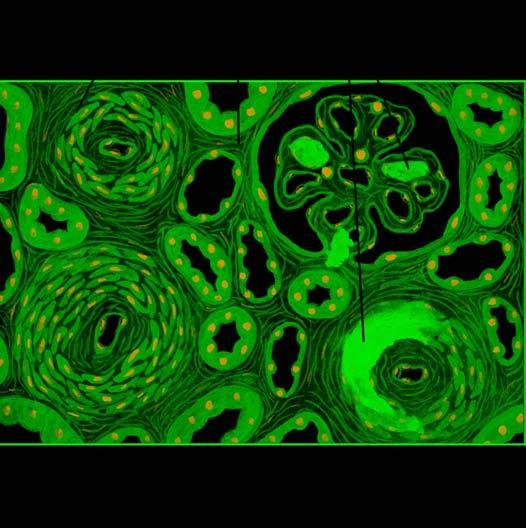how are the vascular changes?
Answer the question using a single word or phrase. Necrotising arteriolitis and hyperplastic intimal sclerosis or onion-skin proliferation 